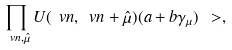Convert formula to latex. <formula><loc_0><loc_0><loc_500><loc_500>\prod _ { \ v n , \hat { \mu } } U ( \ v n , \ v n + \hat { \mu } ) ( a + b \gamma _ { \mu } ) \ > ,</formula> 